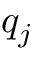<formula> <loc_0><loc_0><loc_500><loc_500>q _ { j }</formula> 